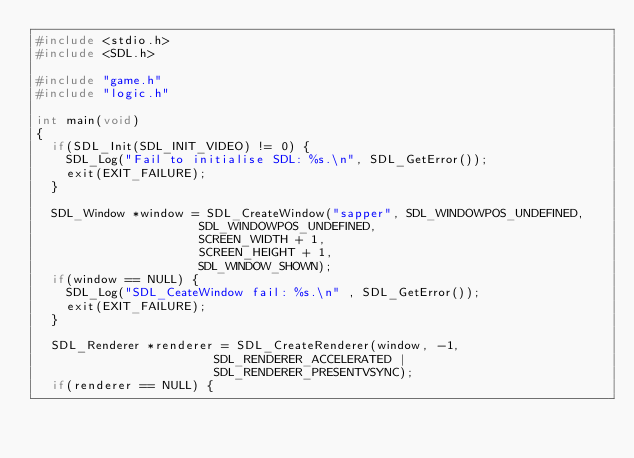Convert code to text. <code><loc_0><loc_0><loc_500><loc_500><_C_>#include <stdio.h>
#include <SDL.h>

#include "game.h"
#include "logic.h"

int main(void)
{
	if(SDL_Init(SDL_INIT_VIDEO) != 0) {
		SDL_Log("Fail to initialise SDL: %s.\n", SDL_GetError());
		exit(EXIT_FAILURE);
	}

	SDL_Window *window = SDL_CreateWindow("sapper", SDL_WINDOWPOS_UNDEFINED,
											SDL_WINDOWPOS_UNDEFINED, 
											SCREEN_WIDTH + 1, 
											SCREEN_HEIGHT + 1, 
											SDL_WINDOW_SHOWN);
	if(window == NULL) {
		SDL_Log("SDL_CeateWindow fail: %s.\n" , SDL_GetError());
		exit(EXIT_FAILURE);
	}

	SDL_Renderer *renderer = SDL_CreateRenderer(window, -1,
												SDL_RENDERER_ACCELERATED | 
												SDL_RENDERER_PRESENTVSYNC);
	if(renderer == NULL) {</code> 